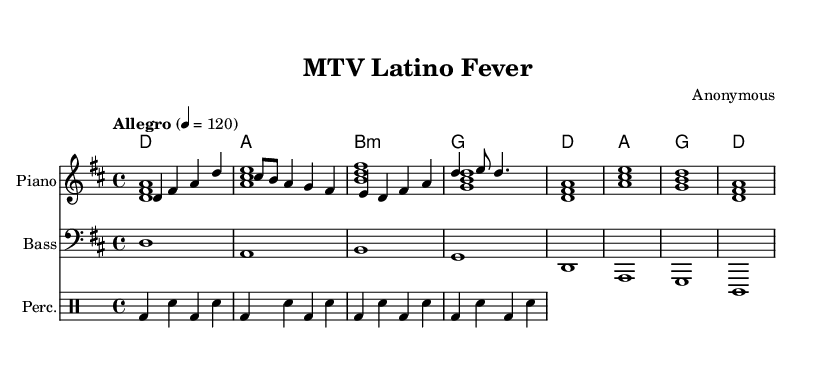What is the key signature of this music? The key signature is indicated by the sharp sign in the music, which is relevant for D major as it has two sharps (F# and C#).
Answer: D major What is the time signature of this music? The time signature is represented at the beginning of the score, where the notation shows four beats in a measure. This is indicated by the 4 over 4 in the music sheet.
Answer: 4/4 What is the tempo marking of this piece? The tempo marking, found at the beginning of the music, indicates the speed of the piece. The term "Allegro" means it should be played quickly, and the specific metronome marking of 120 beats per minute provides a numerical tempo.
Answer: Allegro 4 = 120 How many measures are in the melody? The melody is composed of four measures, which can be counted by visually identifying the vertical lines that separate each measure within the staff.
Answer: 4 measures Which instruments are included in this score? The score specifies multiple staves; it has a piano staff for melody and harmony, a bass staff, and a percussion staff for drums, as indicated by the instrument names at the beginning of each staff.
Answer: Piano, Bass, Percussion What is the harmonic structure used in the piece? The harmony follows a specific chord progression indicated in the chord names; identified chords are D major, A major, B minor, and G major. This can be discerned from the chord symbols aligned with the measures in the sheet music.
Answer: D, A, B minor, G What rhythmic elements are represented in the percussion section? The percussion section includes specific notations for bass drum and snare drum, indicated by the "bd" and "sn" symbols, showing a pattern that repeats. Counting the measures in the drummode text reveals the rhythm's structure and regularity.
Answer: Bass drum and snare drum 